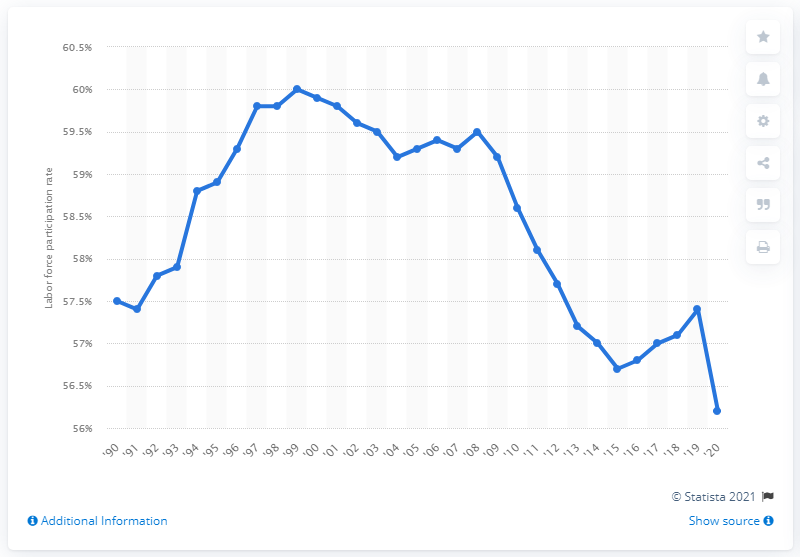Specify some key components in this picture. In 2020, 56.2% of the female labor force participated in the job market. 